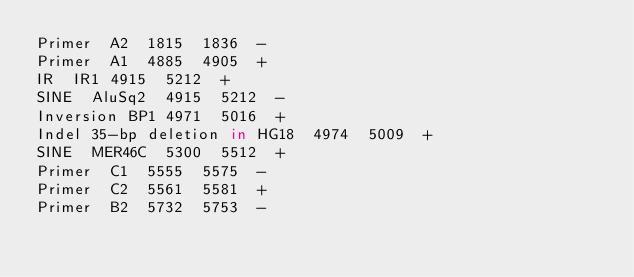<code> <loc_0><loc_0><loc_500><loc_500><_SQL_>Primer	A2	1815	1836	-
Primer	A1	4885	4905	+
IR	IR1	4915	5212	+
SINE	AluSq2	4915	5212	-
Inversion	BP1	4971	5016	+
Indel	35-bp deletion in HG18	4974	5009	+
SINE	MER46C	5300	5512	+
Primer	C1	5555	5575	-
Primer	C2	5561	5581	+
Primer	B2	5732	5753	-</code> 